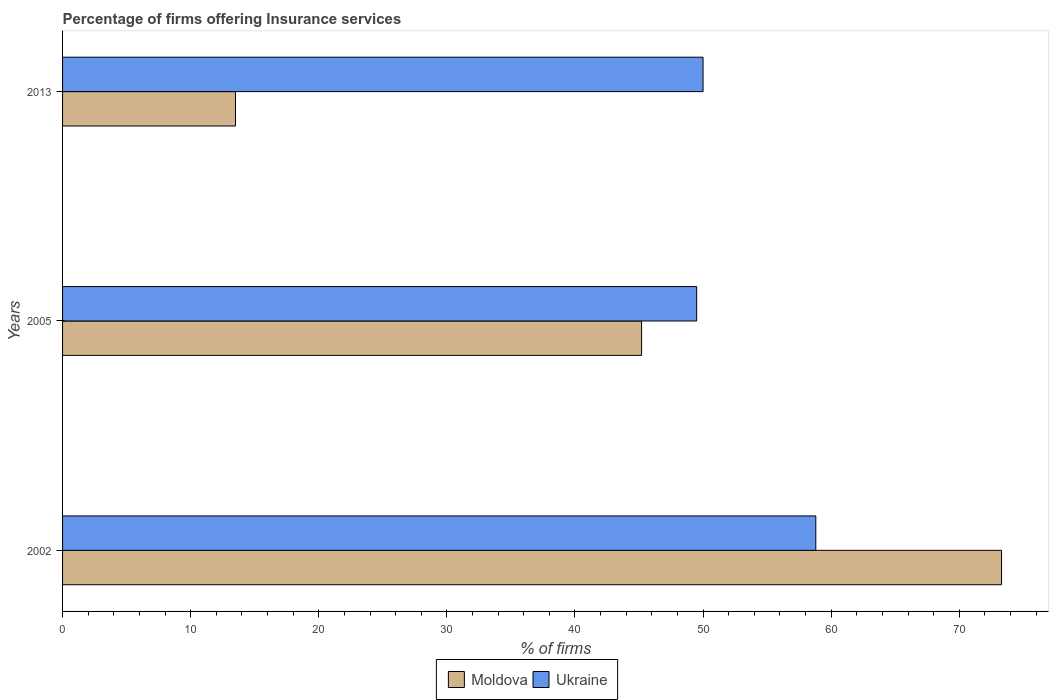How many different coloured bars are there?
Give a very brief answer. 2. How many groups of bars are there?
Provide a short and direct response. 3. Are the number of bars on each tick of the Y-axis equal?
Ensure brevity in your answer.  Yes. How many bars are there on the 1st tick from the bottom?
Keep it short and to the point. 2. What is the label of the 3rd group of bars from the top?
Provide a short and direct response. 2002. In how many cases, is the number of bars for a given year not equal to the number of legend labels?
Ensure brevity in your answer.  0. What is the percentage of firms offering insurance services in Moldova in 2005?
Your answer should be very brief. 45.2. Across all years, what is the maximum percentage of firms offering insurance services in Moldova?
Offer a terse response. 73.3. In which year was the percentage of firms offering insurance services in Moldova maximum?
Make the answer very short. 2002. In which year was the percentage of firms offering insurance services in Ukraine minimum?
Offer a very short reply. 2005. What is the total percentage of firms offering insurance services in Ukraine in the graph?
Your answer should be very brief. 158.3. What is the difference between the percentage of firms offering insurance services in Ukraine in 2002 and that in 2005?
Your response must be concise. 9.3. What is the difference between the percentage of firms offering insurance services in Ukraine in 2013 and the percentage of firms offering insurance services in Moldova in 2002?
Make the answer very short. -23.3. In the year 2013, what is the difference between the percentage of firms offering insurance services in Ukraine and percentage of firms offering insurance services in Moldova?
Provide a succinct answer. 36.5. In how many years, is the percentage of firms offering insurance services in Ukraine greater than 52 %?
Ensure brevity in your answer.  1. What is the ratio of the percentage of firms offering insurance services in Moldova in 2002 to that in 2005?
Provide a succinct answer. 1.62. Is the difference between the percentage of firms offering insurance services in Ukraine in 2002 and 2005 greater than the difference between the percentage of firms offering insurance services in Moldova in 2002 and 2005?
Your answer should be very brief. No. What is the difference between the highest and the second highest percentage of firms offering insurance services in Ukraine?
Make the answer very short. 8.8. What is the difference between the highest and the lowest percentage of firms offering insurance services in Moldova?
Give a very brief answer. 59.8. In how many years, is the percentage of firms offering insurance services in Moldova greater than the average percentage of firms offering insurance services in Moldova taken over all years?
Provide a succinct answer. 2. What does the 2nd bar from the top in 2005 represents?
Your answer should be very brief. Moldova. What does the 1st bar from the bottom in 2005 represents?
Provide a succinct answer. Moldova. How many bars are there?
Keep it short and to the point. 6. Are all the bars in the graph horizontal?
Offer a very short reply. Yes. Does the graph contain grids?
Keep it short and to the point. No. Where does the legend appear in the graph?
Offer a terse response. Bottom center. How many legend labels are there?
Provide a succinct answer. 2. What is the title of the graph?
Your answer should be very brief. Percentage of firms offering Insurance services. Does "Swaziland" appear as one of the legend labels in the graph?
Give a very brief answer. No. What is the label or title of the X-axis?
Ensure brevity in your answer.  % of firms. What is the label or title of the Y-axis?
Your answer should be compact. Years. What is the % of firms in Moldova in 2002?
Keep it short and to the point. 73.3. What is the % of firms in Ukraine in 2002?
Ensure brevity in your answer.  58.8. What is the % of firms of Moldova in 2005?
Give a very brief answer. 45.2. What is the % of firms in Ukraine in 2005?
Offer a terse response. 49.5. What is the % of firms of Moldova in 2013?
Make the answer very short. 13.5. What is the % of firms of Ukraine in 2013?
Offer a very short reply. 50. Across all years, what is the maximum % of firms of Moldova?
Keep it short and to the point. 73.3. Across all years, what is the maximum % of firms of Ukraine?
Your answer should be very brief. 58.8. Across all years, what is the minimum % of firms in Moldova?
Make the answer very short. 13.5. Across all years, what is the minimum % of firms of Ukraine?
Your answer should be compact. 49.5. What is the total % of firms of Moldova in the graph?
Offer a very short reply. 132. What is the total % of firms in Ukraine in the graph?
Give a very brief answer. 158.3. What is the difference between the % of firms in Moldova in 2002 and that in 2005?
Keep it short and to the point. 28.1. What is the difference between the % of firms in Moldova in 2002 and that in 2013?
Your response must be concise. 59.8. What is the difference between the % of firms in Ukraine in 2002 and that in 2013?
Your answer should be very brief. 8.8. What is the difference between the % of firms of Moldova in 2005 and that in 2013?
Ensure brevity in your answer.  31.7. What is the difference between the % of firms of Ukraine in 2005 and that in 2013?
Your answer should be compact. -0.5. What is the difference between the % of firms in Moldova in 2002 and the % of firms in Ukraine in 2005?
Your answer should be very brief. 23.8. What is the difference between the % of firms of Moldova in 2002 and the % of firms of Ukraine in 2013?
Your answer should be very brief. 23.3. What is the average % of firms in Ukraine per year?
Ensure brevity in your answer.  52.77. In the year 2005, what is the difference between the % of firms of Moldova and % of firms of Ukraine?
Provide a succinct answer. -4.3. In the year 2013, what is the difference between the % of firms in Moldova and % of firms in Ukraine?
Provide a succinct answer. -36.5. What is the ratio of the % of firms in Moldova in 2002 to that in 2005?
Provide a short and direct response. 1.62. What is the ratio of the % of firms in Ukraine in 2002 to that in 2005?
Your answer should be very brief. 1.19. What is the ratio of the % of firms in Moldova in 2002 to that in 2013?
Your response must be concise. 5.43. What is the ratio of the % of firms in Ukraine in 2002 to that in 2013?
Provide a short and direct response. 1.18. What is the ratio of the % of firms in Moldova in 2005 to that in 2013?
Provide a short and direct response. 3.35. What is the ratio of the % of firms in Ukraine in 2005 to that in 2013?
Give a very brief answer. 0.99. What is the difference between the highest and the second highest % of firms in Moldova?
Make the answer very short. 28.1. What is the difference between the highest and the second highest % of firms of Ukraine?
Your answer should be very brief. 8.8. What is the difference between the highest and the lowest % of firms of Moldova?
Provide a short and direct response. 59.8. 